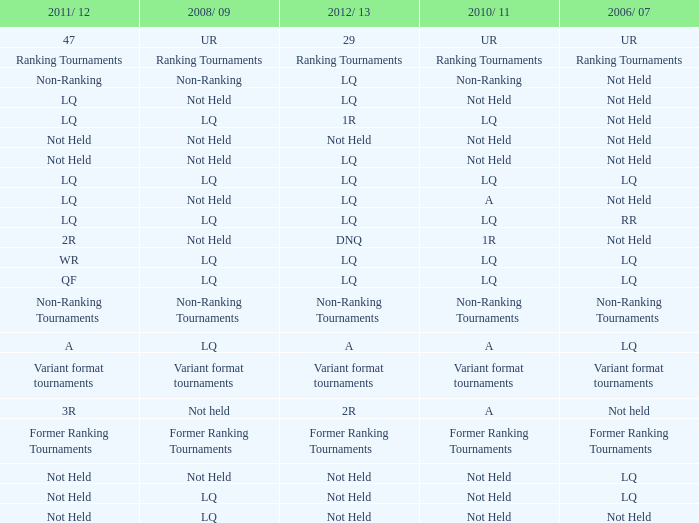What is 2006/07, when 2008/09 is LQ, and when 2010/11 is Not Held? LQ, Not Held. 